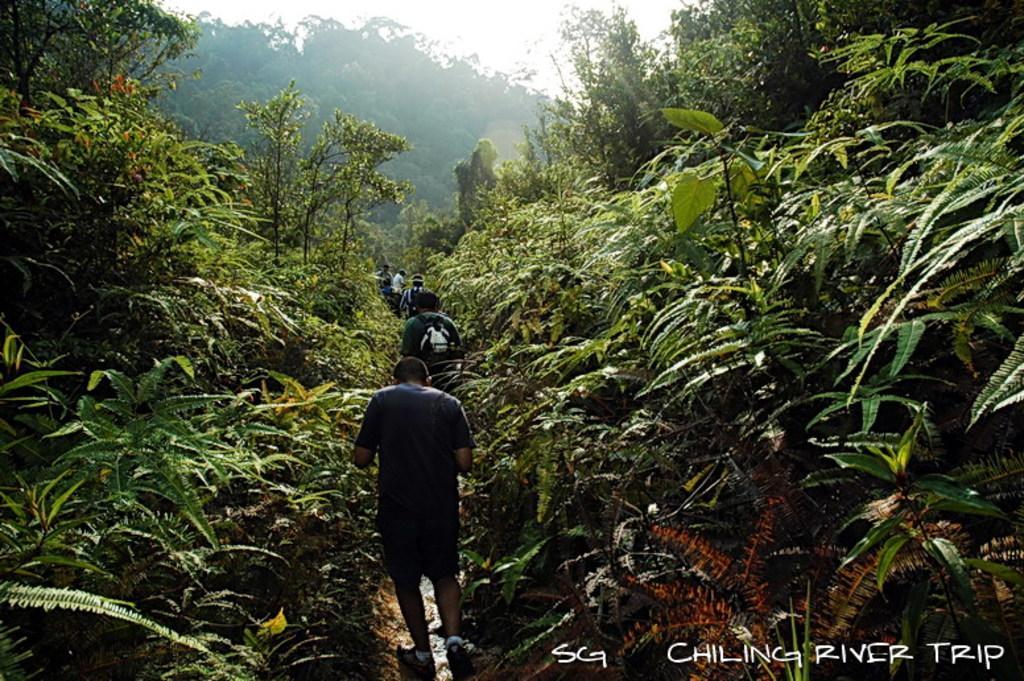Could you give a brief overview of what you see in this image? This picture is clicked outside the city. In the center we can see the group of people seems to be working on the ground and we can see the trees and the sky. At the bottom right corner there is a text on the image. 